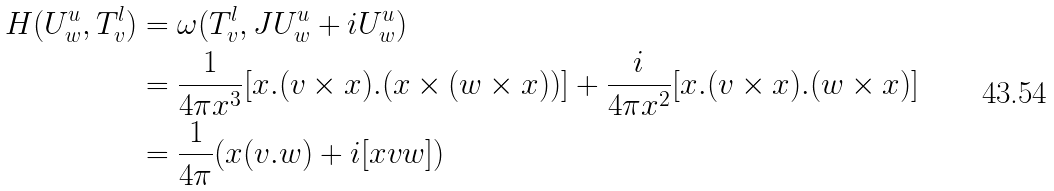<formula> <loc_0><loc_0><loc_500><loc_500>H ( U ^ { u } _ { w } , T ^ { l } _ { v } ) & = \omega ( T ^ { l } _ { v } , J U ^ { u } _ { w } + i U ^ { u } _ { w } ) \\ & = \frac { 1 } { 4 \pi x ^ { 3 } } [ x . ( v \times x ) . ( x \times ( w \times x ) ) ] + \frac { i } { 4 \pi x ^ { 2 } } [ x . ( v \times x ) . ( w \times x ) ] \\ & = \frac { 1 } { 4 \pi } ( x ( v . w ) + i [ x v w ] )</formula> 